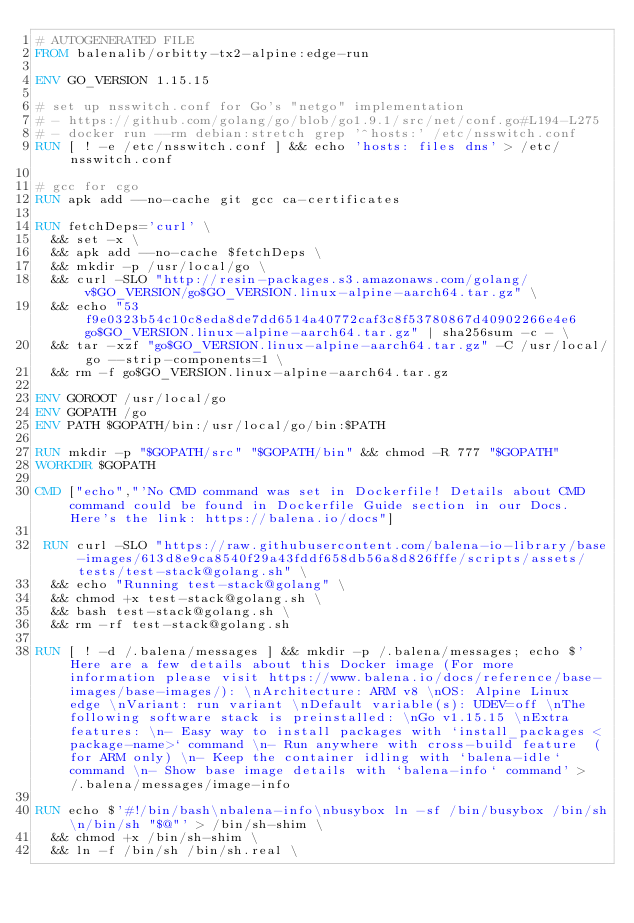Convert code to text. <code><loc_0><loc_0><loc_500><loc_500><_Dockerfile_># AUTOGENERATED FILE
FROM balenalib/orbitty-tx2-alpine:edge-run

ENV GO_VERSION 1.15.15

# set up nsswitch.conf for Go's "netgo" implementation
# - https://github.com/golang/go/blob/go1.9.1/src/net/conf.go#L194-L275
# - docker run --rm debian:stretch grep '^hosts:' /etc/nsswitch.conf
RUN [ ! -e /etc/nsswitch.conf ] && echo 'hosts: files dns' > /etc/nsswitch.conf

# gcc for cgo
RUN apk add --no-cache git gcc ca-certificates

RUN fetchDeps='curl' \
	&& set -x \
	&& apk add --no-cache $fetchDeps \
	&& mkdir -p /usr/local/go \
	&& curl -SLO "http://resin-packages.s3.amazonaws.com/golang/v$GO_VERSION/go$GO_VERSION.linux-alpine-aarch64.tar.gz" \
	&& echo "53f9e0323b54c10c8eda8de7dd6514a40772caf3c8f53780867d40902266e4e6  go$GO_VERSION.linux-alpine-aarch64.tar.gz" | sha256sum -c - \
	&& tar -xzf "go$GO_VERSION.linux-alpine-aarch64.tar.gz" -C /usr/local/go --strip-components=1 \
	&& rm -f go$GO_VERSION.linux-alpine-aarch64.tar.gz

ENV GOROOT /usr/local/go
ENV GOPATH /go
ENV PATH $GOPATH/bin:/usr/local/go/bin:$PATH

RUN mkdir -p "$GOPATH/src" "$GOPATH/bin" && chmod -R 777 "$GOPATH"
WORKDIR $GOPATH

CMD ["echo","'No CMD command was set in Dockerfile! Details about CMD command could be found in Dockerfile Guide section in our Docs. Here's the link: https://balena.io/docs"]

 RUN curl -SLO "https://raw.githubusercontent.com/balena-io-library/base-images/613d8e9ca8540f29a43fddf658db56a8d826fffe/scripts/assets/tests/test-stack@golang.sh" \
  && echo "Running test-stack@golang" \
  && chmod +x test-stack@golang.sh \
  && bash test-stack@golang.sh \
  && rm -rf test-stack@golang.sh 

RUN [ ! -d /.balena/messages ] && mkdir -p /.balena/messages; echo $'Here are a few details about this Docker image (For more information please visit https://www.balena.io/docs/reference/base-images/base-images/): \nArchitecture: ARM v8 \nOS: Alpine Linux edge \nVariant: run variant \nDefault variable(s): UDEV=off \nThe following software stack is preinstalled: \nGo v1.15.15 \nExtra features: \n- Easy way to install packages with `install_packages <package-name>` command \n- Run anywhere with cross-build feature  (for ARM only) \n- Keep the container idling with `balena-idle` command \n- Show base image details with `balena-info` command' > /.balena/messages/image-info

RUN echo $'#!/bin/bash\nbalena-info\nbusybox ln -sf /bin/busybox /bin/sh\n/bin/sh "$@"' > /bin/sh-shim \
	&& chmod +x /bin/sh-shim \
	&& ln -f /bin/sh /bin/sh.real \</code> 